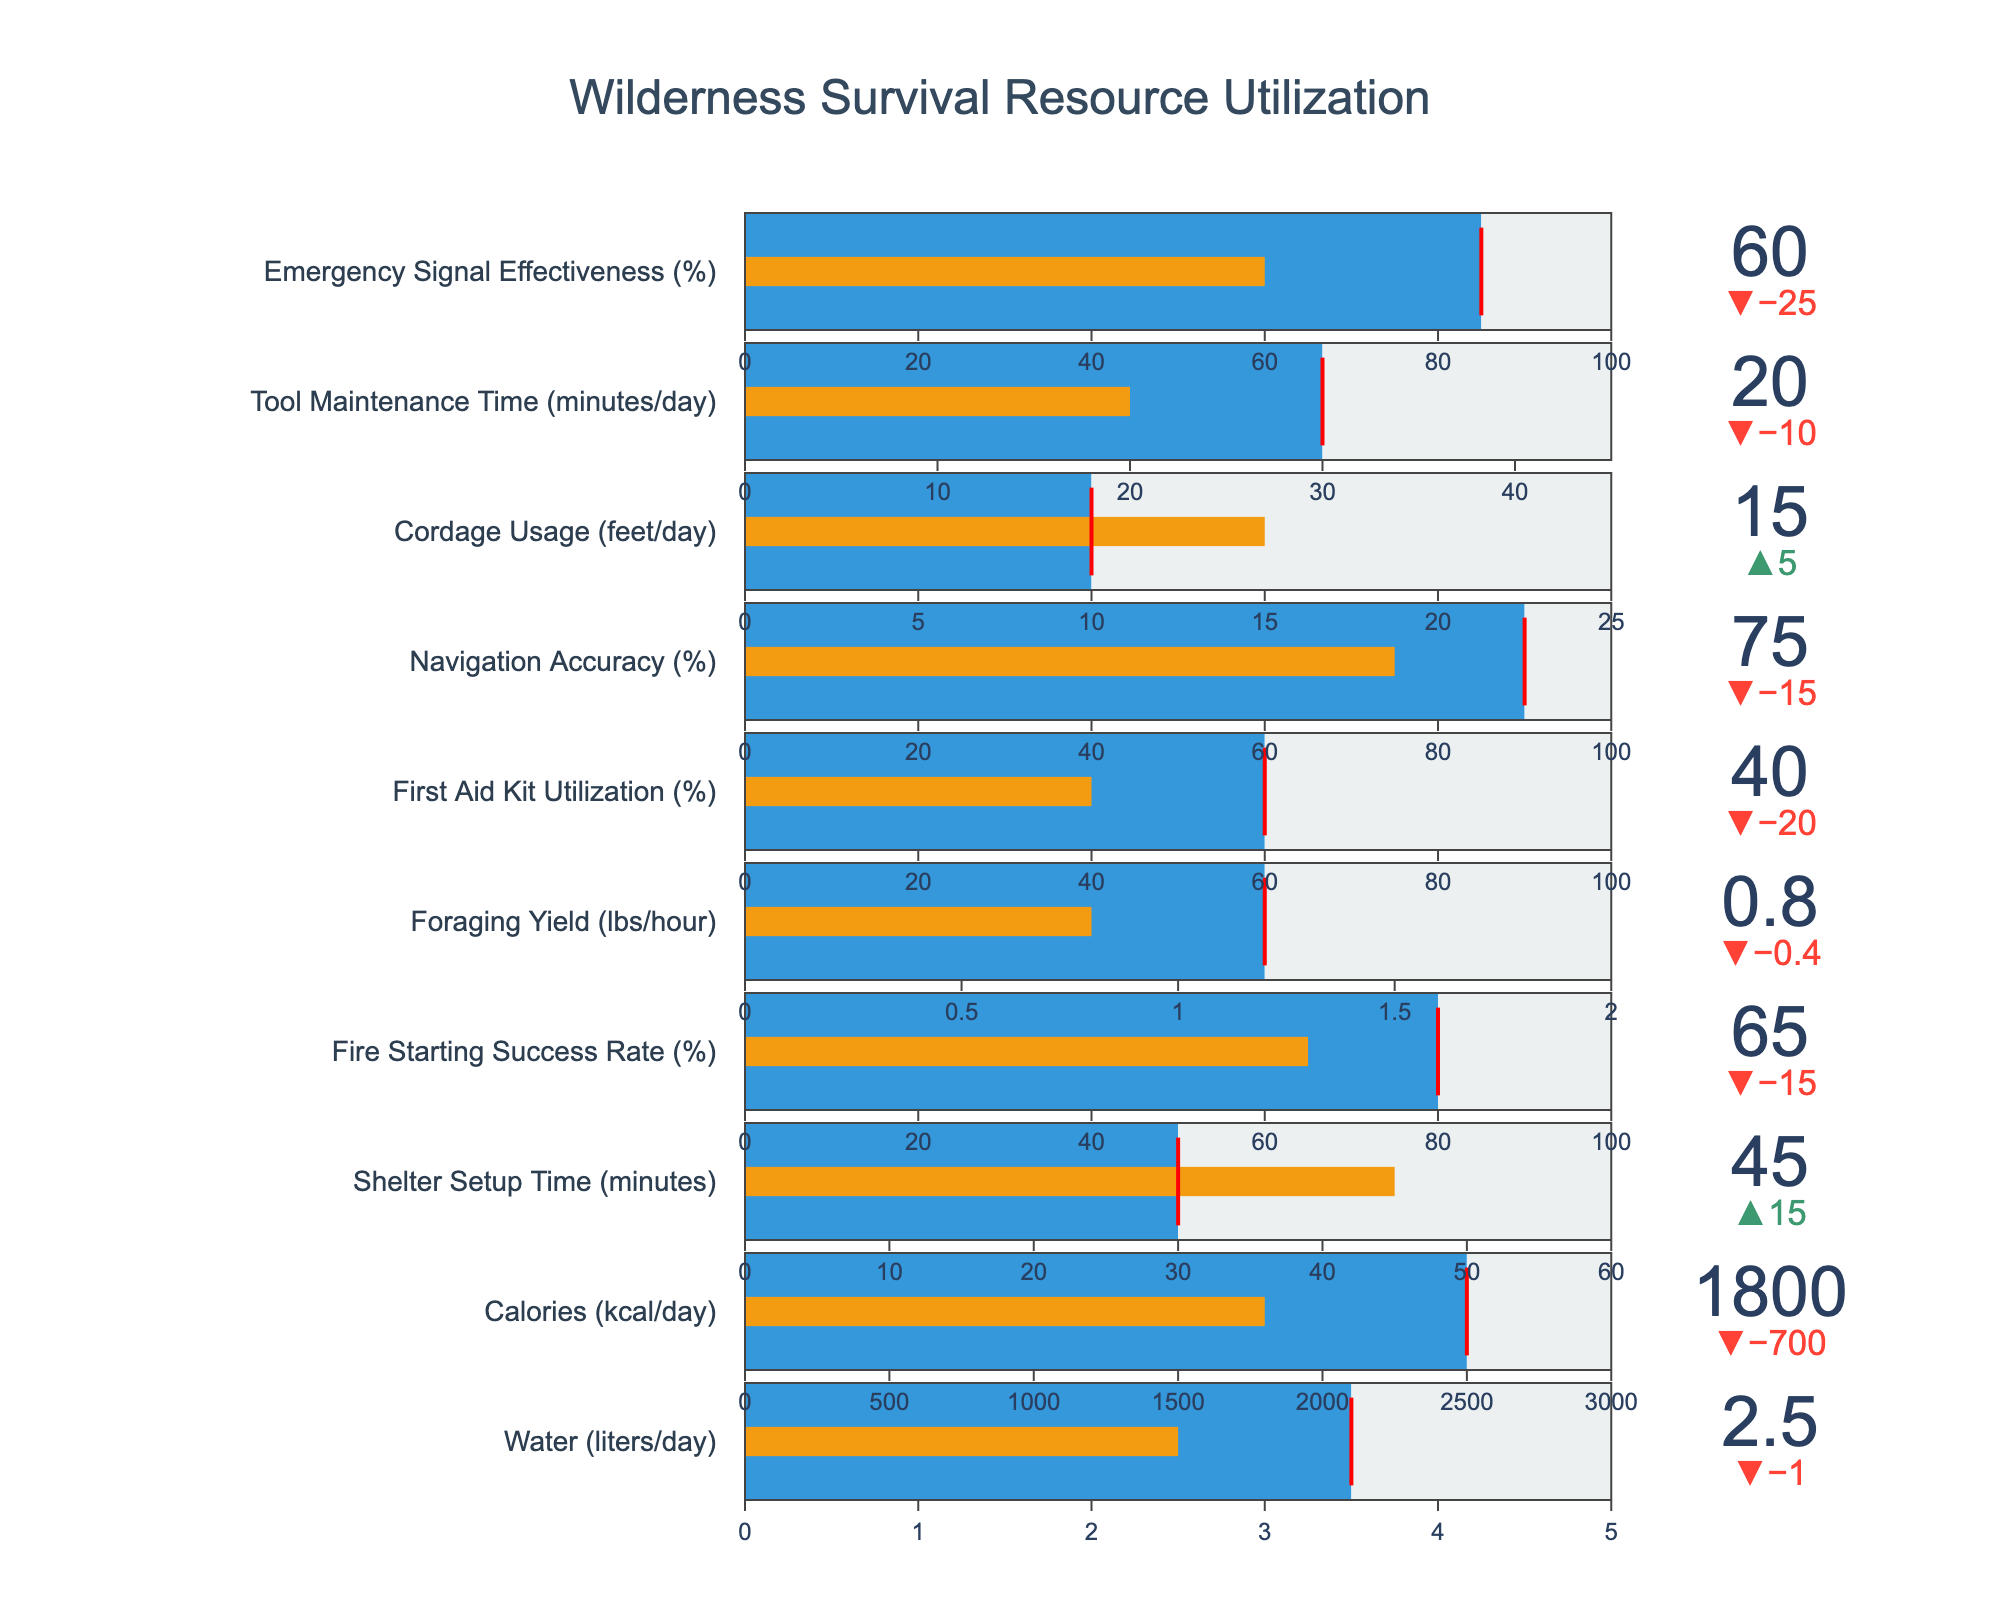What's the title of the figure? The title is prominently displayed at the top center of the figure. It reads "Wilderness Survival Resource Utilization".
Answer: Wilderness Survival Resource Utilization How much is the Actual Usage of water compared to the Ideal Usage? The Actual Usage for water is shown as 2.5 liters/day, and the Ideal Usage is depicted as 3.5 liters/day. The difference is simply the Ideal Usage minus the Actual Usage, which is 3.5 - 2.5.
Answer: 1 liter/day less Which resource has the highest deviation from its ideal usage? By looking at the delta values (differences between actual and ideal usage) for all resources, the most significant deviation is seen in the "Emergency Signal Effectiveness" with 60% actual compared to 85% ideal, making a deviation of 25%.
Answer: Emergency Signal Effectiveness What is the percentage of Navigation Accuracy compared to its ideal level? The Actual Usage of Navigation Accuracy is shown as 75%, while the Ideal Usage is 90%. To find the percentage of the actual compared to the ideal, we calculate (75/90) * 100%.
Answer: ≈83.33% How does the Fire Starting Success Rate compare with ideal and maximum levels? The Fire Starting Success Rate's Actual Usage is 65%, its Ideal Usage is 80%, and the Maximum Capacity is 100%. Therefore, the actual usage is less than the ideal and maximum levels.
Answer: Less than both ideal and maximum For which resource is the Actual Usage closest to the Ideal Usage? By comparing the delta values (absolute differences) of all resources, the "Tool Maintenance Time" has the smallest deviation, with Actual Usage at 20 minutes/day and Ideal Usage at 30 minutes/day, giving a difference of 10 minutes/day.
Answer: Tool Maintenance Time What percentage of the ideal foraging yield is actually achieved? The Actual Usage for foraging yield is 0.8 lbs/hour, and the Ideal Usage is 1.2 lbs/hour. To find the percentage of the actual compared to the ideal, we calculate (0.8 / 1.2) * 100%.
Answer: ≈66.67% Which resource utilization is the most efficient, meaning closest to 100% of its capacity? Efficient usage means the smallest difference between actual and the maximum capacity. By examining the values, the "Cordage Usage" with Actual Usage of 15 feet/day and Maximum Capacity of 25 feet/day has the lowest percentage shortfall from maximum, which is (25 - 15) / 25 * 100%.
Answer: Cordage Usage How much more fire starting success is needed to reach the ideal level? The Actual Usage for Fire Starting Success Rate is 65%, and the Ideal Usage is 80%. Therefore, the additional success rate needed is 80% - 65%.
Answer: 15% more 